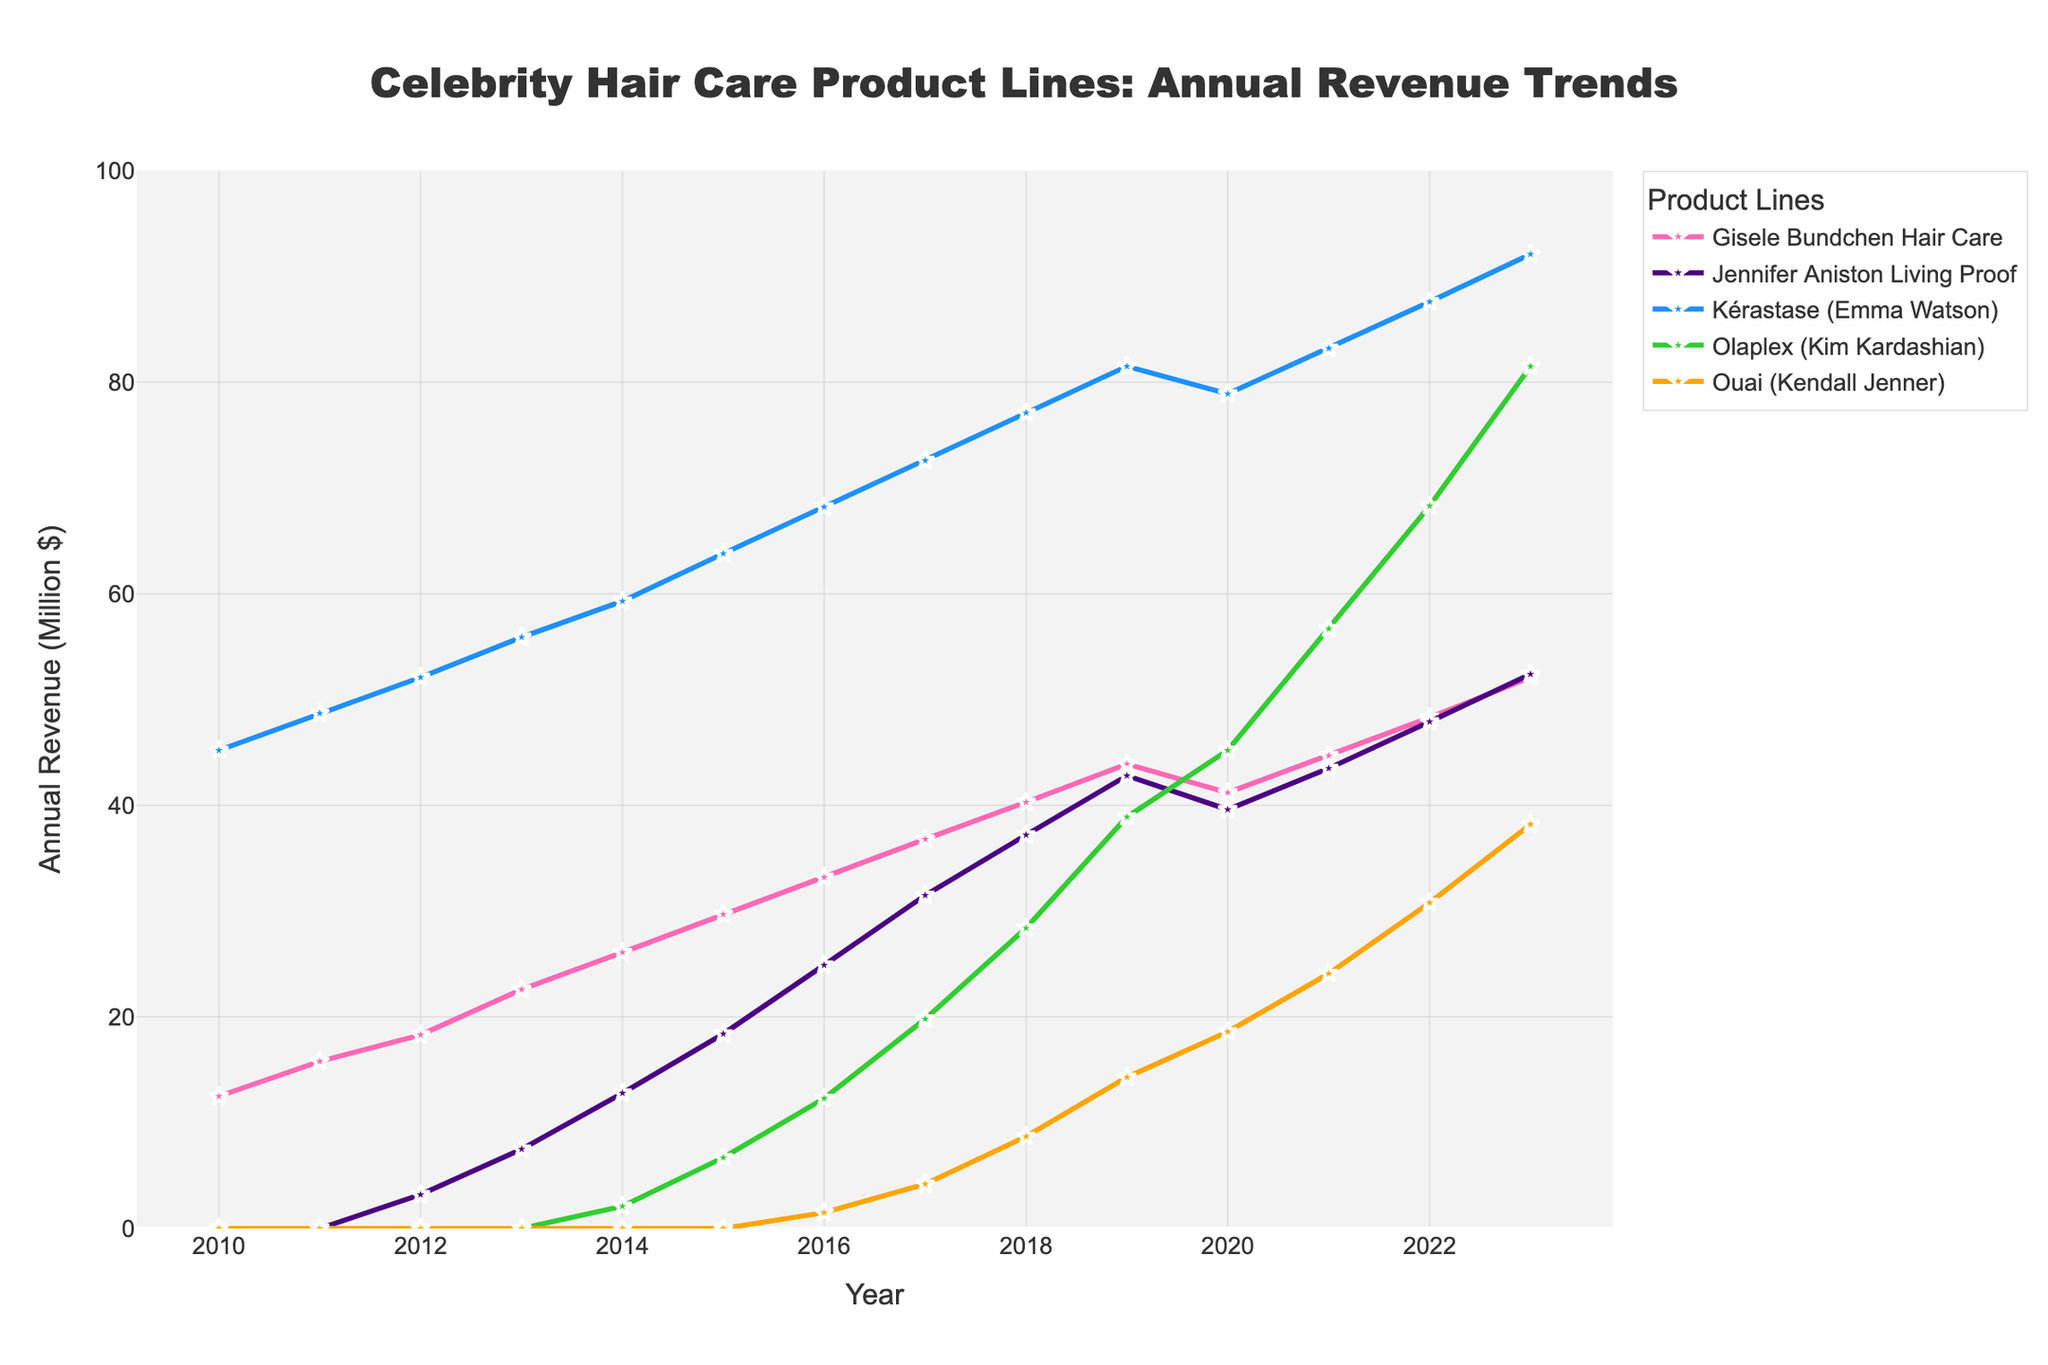What is the trend in annual revenue for the Ouai (Kendall Jenner) product line from 2016 to 2023? To determine the trend for the Ouai (Kendall Jenner) product line, look at the annual revenue values from 2016 to 2023. The revenue starts at $1.5 million in 2016 and increases gradually each year, reaching $38.2 million in 2023.
Answer: Increasing Which product line had the highest revenue in 2011? In 2011, compare the revenue values for all product lines. The Kérastase (Emma Watson) has the highest revenue at $48.7 million.
Answer: Kérastase (Emma Watson) How did the revenue for Olaplex (Kim Kardashian) change from 2019 to 2023? First, note the revenue of Olaplex in 2019 ($38.9 million) and in 2023 ($81.5 million). The revenue increased by $42.6 million over this period.
Answer: Increased by $42.6 million Which product line shows the most consistent growth over the entire period from 2010 to 2023? Evaluate the revenue trends for all product lines from 2010 to 2023. Kérastase (Emma Watson) shows consistent growth every year without any declines.
Answer: Kérastase (Emma Watson) In which year did Jennifer Aniston Living Proof product line surpass $20 million in annual revenue? Check the yearly revenue for Jennifer Aniston Living Proof. The revenue surpasses $20 million in 2016 when it was $24.9 million.
Answer: 2016 What is the combined revenue of Gisele Bundchen Hair Care and Ouai (Kendall Jenner) in 2020? Sum the revenue values for Gisele Bundchen Hair Care ($41.2 million) and Ouai (Kendall Jenner) ($18.6 million) in 2020. The combined revenue is $41.2 million + $18.6 million = $59.8 million.
Answer: $59.8 million Which product line had zero revenue until 2014 and then saw an increase? Identify the product lines that had zero revenue until 2014 and then observed an increase. Olaplex (Kim Kardashian) had zero revenue until 2014 and then increased in the following years.
Answer: Olaplex (Kim Kardashian) Has any product line shown a revenue decline between two consecutive years? If so, which year and product line? Look for decreases in revenue between consecutive years for each product line. Gisele Bundchen Hair Care shows a decline from 2019 ($43.9 million) to 2020 ($41.2 million).
Answer: Gisele Bundchen Hair Care from 2019 to 2020 By how much did the revenue of Jennifer Aniston Living Proof increase from 2012 to 2015? Note the revenue for Jennifer Aniston Living Proof in 2012 ($3.2 million) and in 2015 ($18.4 million). The increase is $18.4 million - $3.2 million = $15.2 million.
Answer: $15.2 million 